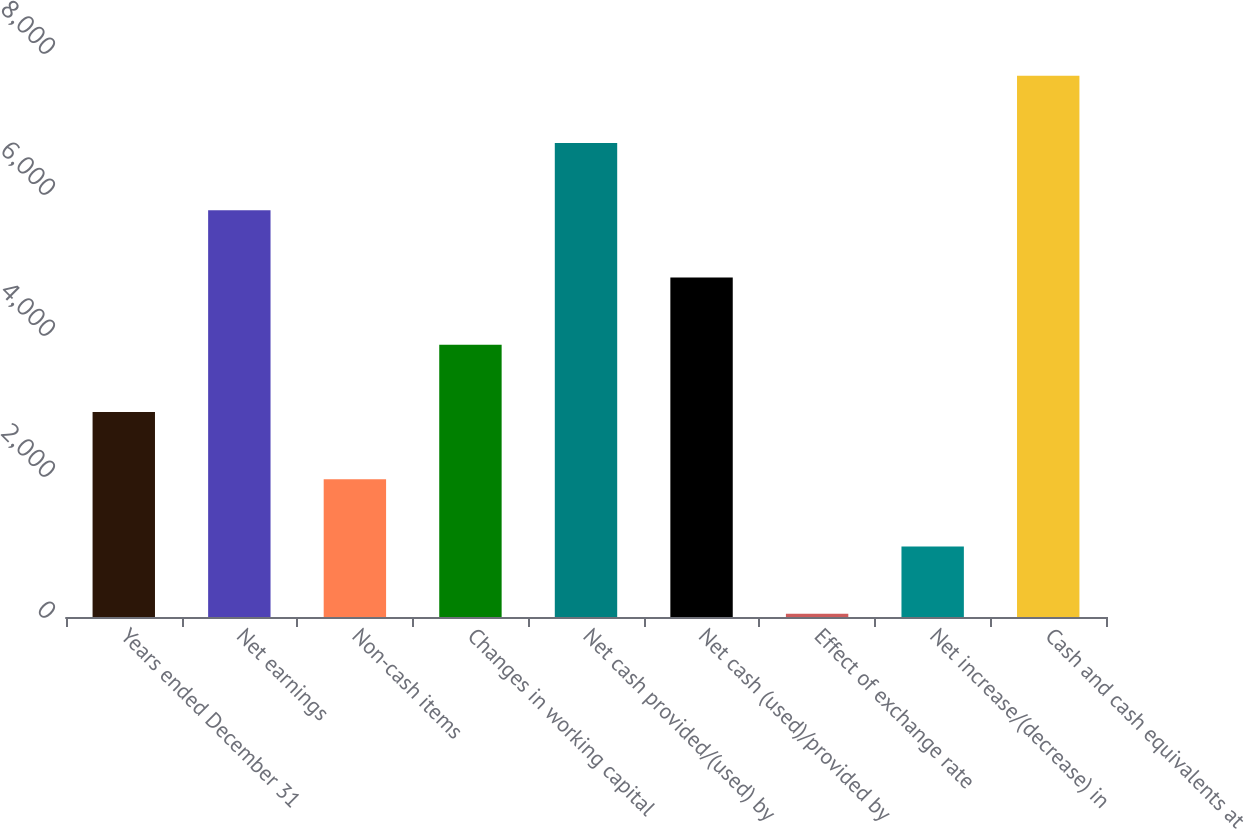Convert chart. <chart><loc_0><loc_0><loc_500><loc_500><bar_chart><fcel>Years ended December 31<fcel>Net earnings<fcel>Non-cash items<fcel>Changes in working capital<fcel>Net cash provided/(used) by<fcel>Net cash (used)/provided by<fcel>Effect of exchange rate<fcel>Net increase/(decrease) in<fcel>Cash and cash equivalents at<nl><fcel>2907.4<fcel>5768.8<fcel>1953.6<fcel>3861.2<fcel>6722.6<fcel>4815<fcel>46<fcel>999.8<fcel>7676.4<nl></chart> 